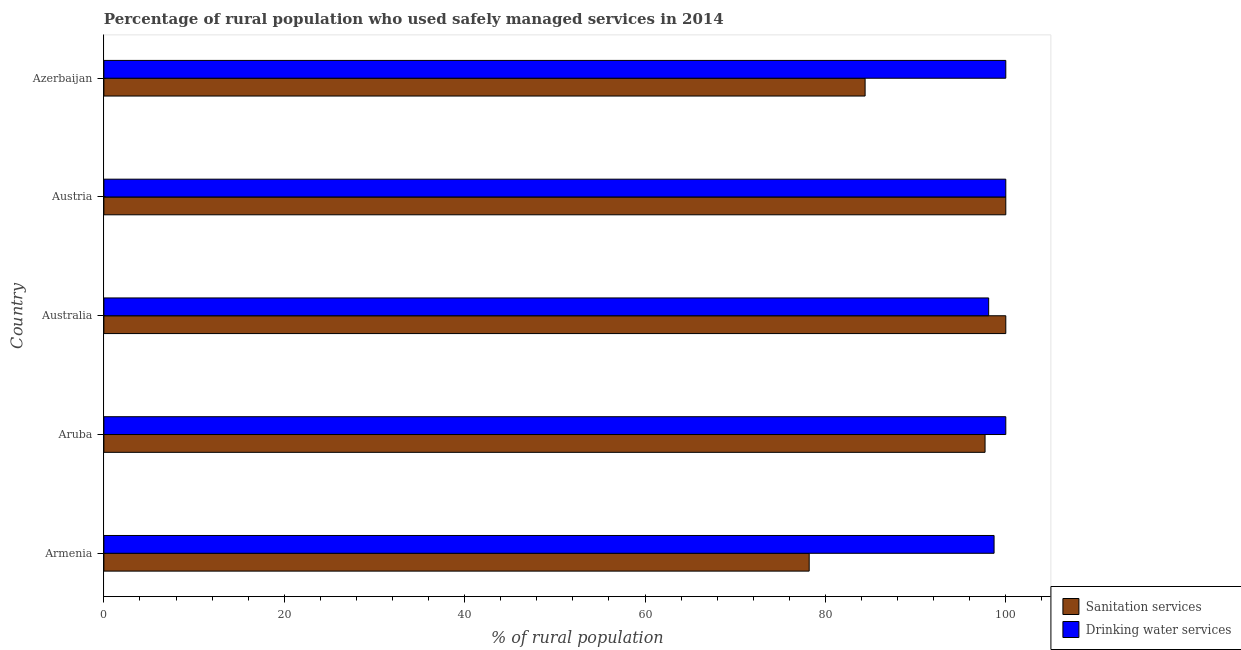How many different coloured bars are there?
Your answer should be compact. 2. How many bars are there on the 1st tick from the top?
Provide a succinct answer. 2. How many bars are there on the 2nd tick from the bottom?
Provide a short and direct response. 2. Across all countries, what is the minimum percentage of rural population who used sanitation services?
Provide a short and direct response. 78.2. In which country was the percentage of rural population who used drinking water services maximum?
Give a very brief answer. Aruba. What is the total percentage of rural population who used sanitation services in the graph?
Ensure brevity in your answer.  460.3. What is the difference between the percentage of rural population who used sanitation services in Armenia and that in Aruba?
Offer a terse response. -19.5. What is the difference between the percentage of rural population who used sanitation services in Austria and the percentage of rural population who used drinking water services in Armenia?
Your answer should be very brief. 1.3. What is the average percentage of rural population who used sanitation services per country?
Provide a succinct answer. 92.06. What is the ratio of the percentage of rural population who used sanitation services in Armenia to that in Aruba?
Make the answer very short. 0.8. Is the percentage of rural population who used drinking water services in Aruba less than that in Australia?
Your answer should be compact. No. What is the difference between the highest and the second highest percentage of rural population who used sanitation services?
Your answer should be compact. 0. What is the difference between the highest and the lowest percentage of rural population who used sanitation services?
Ensure brevity in your answer.  21.8. In how many countries, is the percentage of rural population who used sanitation services greater than the average percentage of rural population who used sanitation services taken over all countries?
Offer a very short reply. 3. What does the 1st bar from the top in Australia represents?
Provide a short and direct response. Drinking water services. What does the 2nd bar from the bottom in Azerbaijan represents?
Keep it short and to the point. Drinking water services. How many countries are there in the graph?
Keep it short and to the point. 5. Are the values on the major ticks of X-axis written in scientific E-notation?
Your answer should be very brief. No. Does the graph contain any zero values?
Make the answer very short. No. How are the legend labels stacked?
Give a very brief answer. Vertical. What is the title of the graph?
Offer a terse response. Percentage of rural population who used safely managed services in 2014. What is the label or title of the X-axis?
Your response must be concise. % of rural population. What is the label or title of the Y-axis?
Your answer should be compact. Country. What is the % of rural population of Sanitation services in Armenia?
Offer a terse response. 78.2. What is the % of rural population of Drinking water services in Armenia?
Offer a terse response. 98.7. What is the % of rural population in Sanitation services in Aruba?
Make the answer very short. 97.7. What is the % of rural population in Drinking water services in Aruba?
Provide a short and direct response. 100. What is the % of rural population in Drinking water services in Australia?
Ensure brevity in your answer.  98.1. What is the % of rural population in Sanitation services in Austria?
Offer a very short reply. 100. What is the % of rural population in Drinking water services in Austria?
Make the answer very short. 100. What is the % of rural population of Sanitation services in Azerbaijan?
Provide a succinct answer. 84.4. What is the % of rural population in Drinking water services in Azerbaijan?
Your answer should be very brief. 100. Across all countries, what is the maximum % of rural population in Sanitation services?
Keep it short and to the point. 100. Across all countries, what is the minimum % of rural population in Sanitation services?
Your answer should be compact. 78.2. Across all countries, what is the minimum % of rural population in Drinking water services?
Ensure brevity in your answer.  98.1. What is the total % of rural population of Sanitation services in the graph?
Your response must be concise. 460.3. What is the total % of rural population in Drinking water services in the graph?
Keep it short and to the point. 496.8. What is the difference between the % of rural population of Sanitation services in Armenia and that in Aruba?
Keep it short and to the point. -19.5. What is the difference between the % of rural population in Drinking water services in Armenia and that in Aruba?
Ensure brevity in your answer.  -1.3. What is the difference between the % of rural population in Sanitation services in Armenia and that in Australia?
Make the answer very short. -21.8. What is the difference between the % of rural population of Sanitation services in Armenia and that in Austria?
Your answer should be compact. -21.8. What is the difference between the % of rural population in Sanitation services in Aruba and that in Australia?
Offer a very short reply. -2.3. What is the difference between the % of rural population of Drinking water services in Aruba and that in Australia?
Offer a terse response. 1.9. What is the difference between the % of rural population in Sanitation services in Aruba and that in Austria?
Your response must be concise. -2.3. What is the difference between the % of rural population in Drinking water services in Aruba and that in Austria?
Your answer should be compact. 0. What is the difference between the % of rural population of Drinking water services in Aruba and that in Azerbaijan?
Offer a very short reply. 0. What is the difference between the % of rural population of Drinking water services in Australia and that in Austria?
Offer a terse response. -1.9. What is the difference between the % of rural population in Drinking water services in Australia and that in Azerbaijan?
Keep it short and to the point. -1.9. What is the difference between the % of rural population in Sanitation services in Austria and that in Azerbaijan?
Your answer should be compact. 15.6. What is the difference between the % of rural population of Sanitation services in Armenia and the % of rural population of Drinking water services in Aruba?
Your answer should be very brief. -21.8. What is the difference between the % of rural population of Sanitation services in Armenia and the % of rural population of Drinking water services in Australia?
Keep it short and to the point. -19.9. What is the difference between the % of rural population in Sanitation services in Armenia and the % of rural population in Drinking water services in Austria?
Keep it short and to the point. -21.8. What is the difference between the % of rural population of Sanitation services in Armenia and the % of rural population of Drinking water services in Azerbaijan?
Provide a succinct answer. -21.8. What is the difference between the % of rural population of Sanitation services in Aruba and the % of rural population of Drinking water services in Australia?
Make the answer very short. -0.4. What is the average % of rural population in Sanitation services per country?
Offer a very short reply. 92.06. What is the average % of rural population of Drinking water services per country?
Provide a short and direct response. 99.36. What is the difference between the % of rural population in Sanitation services and % of rural population in Drinking water services in Armenia?
Provide a short and direct response. -20.5. What is the difference between the % of rural population of Sanitation services and % of rural population of Drinking water services in Austria?
Ensure brevity in your answer.  0. What is the difference between the % of rural population of Sanitation services and % of rural population of Drinking water services in Azerbaijan?
Make the answer very short. -15.6. What is the ratio of the % of rural population in Sanitation services in Armenia to that in Aruba?
Your answer should be very brief. 0.8. What is the ratio of the % of rural population of Drinking water services in Armenia to that in Aruba?
Provide a succinct answer. 0.99. What is the ratio of the % of rural population of Sanitation services in Armenia to that in Australia?
Provide a short and direct response. 0.78. What is the ratio of the % of rural population of Sanitation services in Armenia to that in Austria?
Give a very brief answer. 0.78. What is the ratio of the % of rural population in Drinking water services in Armenia to that in Austria?
Offer a terse response. 0.99. What is the ratio of the % of rural population in Sanitation services in Armenia to that in Azerbaijan?
Provide a short and direct response. 0.93. What is the ratio of the % of rural population in Drinking water services in Armenia to that in Azerbaijan?
Offer a terse response. 0.99. What is the ratio of the % of rural population in Sanitation services in Aruba to that in Australia?
Ensure brevity in your answer.  0.98. What is the ratio of the % of rural population of Drinking water services in Aruba to that in Australia?
Offer a very short reply. 1.02. What is the ratio of the % of rural population of Sanitation services in Aruba to that in Austria?
Give a very brief answer. 0.98. What is the ratio of the % of rural population in Drinking water services in Aruba to that in Austria?
Ensure brevity in your answer.  1. What is the ratio of the % of rural population of Sanitation services in Aruba to that in Azerbaijan?
Keep it short and to the point. 1.16. What is the ratio of the % of rural population in Sanitation services in Australia to that in Austria?
Offer a very short reply. 1. What is the ratio of the % of rural population in Drinking water services in Australia to that in Austria?
Ensure brevity in your answer.  0.98. What is the ratio of the % of rural population of Sanitation services in Australia to that in Azerbaijan?
Your answer should be very brief. 1.18. What is the ratio of the % of rural population of Sanitation services in Austria to that in Azerbaijan?
Provide a succinct answer. 1.18. What is the ratio of the % of rural population in Drinking water services in Austria to that in Azerbaijan?
Your answer should be compact. 1. What is the difference between the highest and the second highest % of rural population of Sanitation services?
Provide a succinct answer. 0. What is the difference between the highest and the second highest % of rural population of Drinking water services?
Offer a very short reply. 0. What is the difference between the highest and the lowest % of rural population of Sanitation services?
Provide a succinct answer. 21.8. 